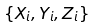<formula> <loc_0><loc_0><loc_500><loc_500>\left \{ X _ { i } , Y _ { i } , Z _ { i } \right \}</formula> 